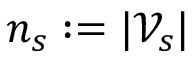Convert formula to latex. <formula><loc_0><loc_0><loc_500><loc_500>n _ { s } \colon = | \mathcal { V } _ { s } |</formula> 